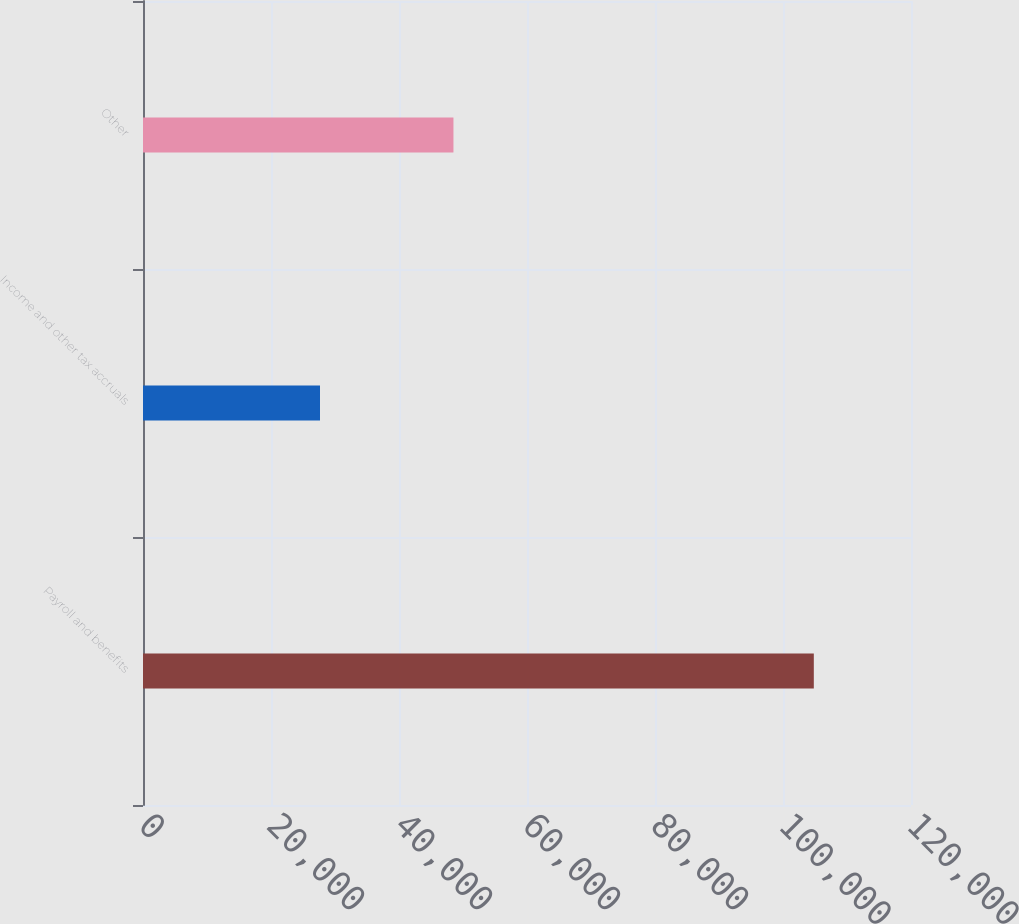<chart> <loc_0><loc_0><loc_500><loc_500><bar_chart><fcel>Payroll and benefits<fcel>Income and other tax accruals<fcel>Other<nl><fcel>104815<fcel>27656<fcel>48508<nl></chart> 